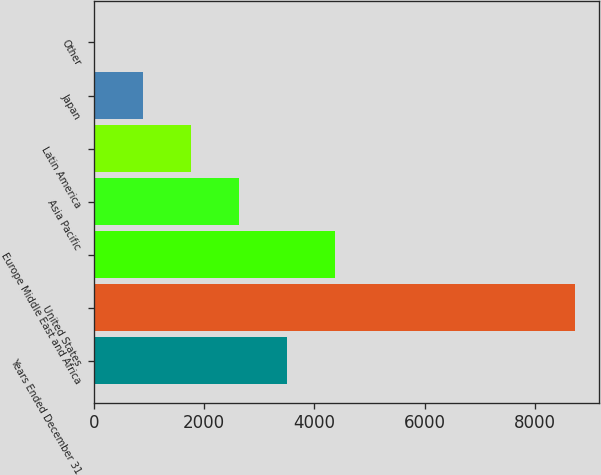Convert chart. <chart><loc_0><loc_0><loc_500><loc_500><bar_chart><fcel>Years Ended December 31<fcel>United States<fcel>Europe Middle East and Africa<fcel>Asia Pacific<fcel>Latin America<fcel>Japan<fcel>Other<nl><fcel>3498.6<fcel>8727<fcel>4370<fcel>2627.2<fcel>1755.8<fcel>884.4<fcel>13<nl></chart> 